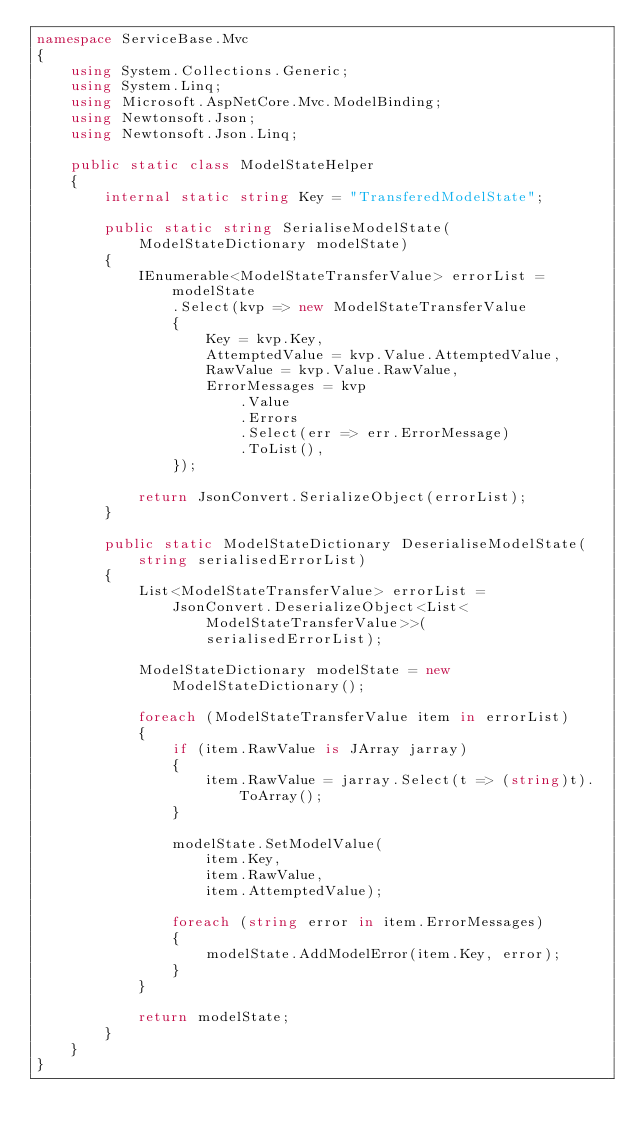Convert code to text. <code><loc_0><loc_0><loc_500><loc_500><_C#_>namespace ServiceBase.Mvc
{
    using System.Collections.Generic;
    using System.Linq;
    using Microsoft.AspNetCore.Mvc.ModelBinding;
    using Newtonsoft.Json;
    using Newtonsoft.Json.Linq;

    public static class ModelStateHelper
    {
        internal static string Key = "TransferedModelState";

        public static string SerialiseModelState(
            ModelStateDictionary modelState)
        {
            IEnumerable<ModelStateTransferValue> errorList = modelState
                .Select(kvp => new ModelStateTransferValue
                {
                    Key = kvp.Key,
                    AttemptedValue = kvp.Value.AttemptedValue,
                    RawValue = kvp.Value.RawValue,
                    ErrorMessages = kvp
                        .Value
                        .Errors
                        .Select(err => err.ErrorMessage)
                        .ToList(),
                });

            return JsonConvert.SerializeObject(errorList);
        }

        public static ModelStateDictionary DeserialiseModelState(
            string serialisedErrorList)
        {
            List<ModelStateTransferValue> errorList =
                JsonConvert.DeserializeObject<List<ModelStateTransferValue>>(
                    serialisedErrorList);

            ModelStateDictionary modelState = new ModelStateDictionary();

            foreach (ModelStateTransferValue item in errorList)
            {
                if (item.RawValue is JArray jarray)
                {
                    item.RawValue = jarray.Select(t => (string)t).ToArray();
                }

                modelState.SetModelValue(
                    item.Key,
                    item.RawValue,
                    item.AttemptedValue);

                foreach (string error in item.ErrorMessages)
                {
                    modelState.AddModelError(item.Key, error);
                }
            }

            return modelState;
        }
    }
}
</code> 